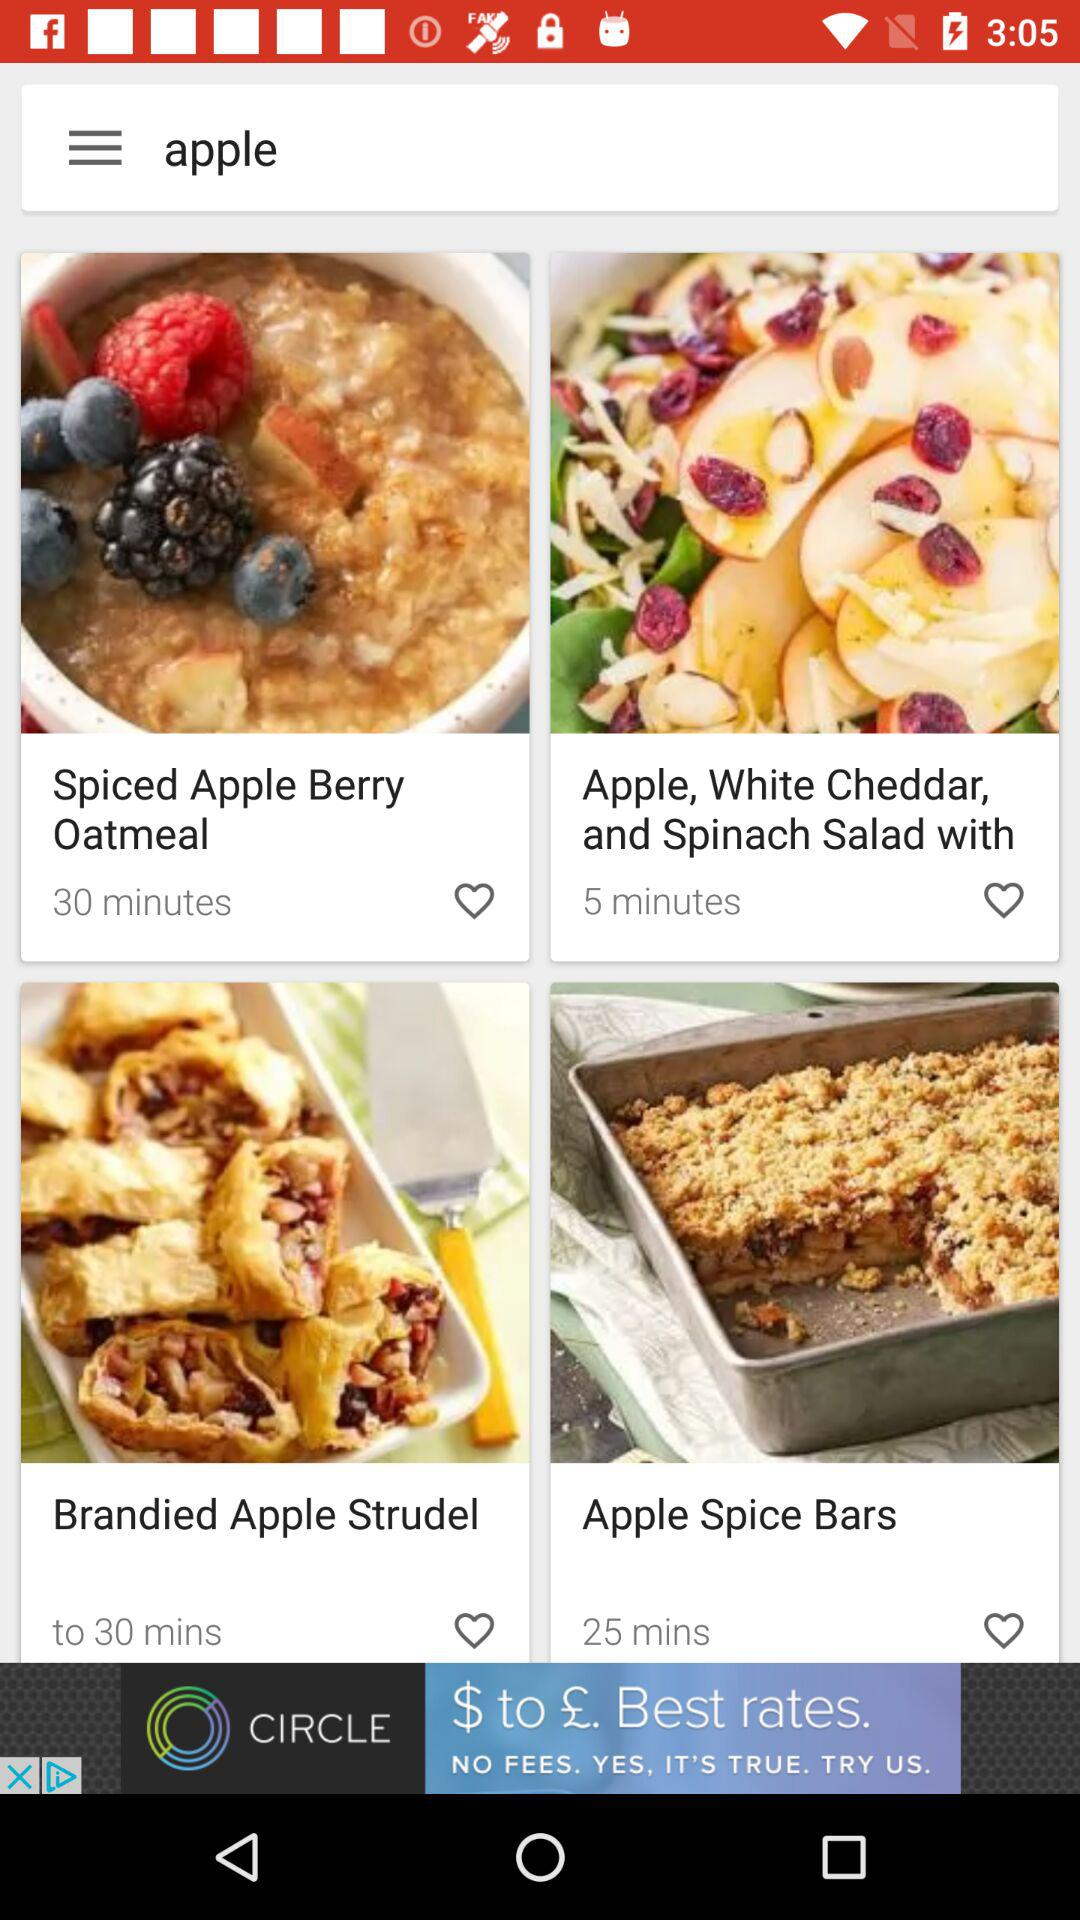How many recipes take less than 30 minutes?
Answer the question using a single word or phrase. 2 